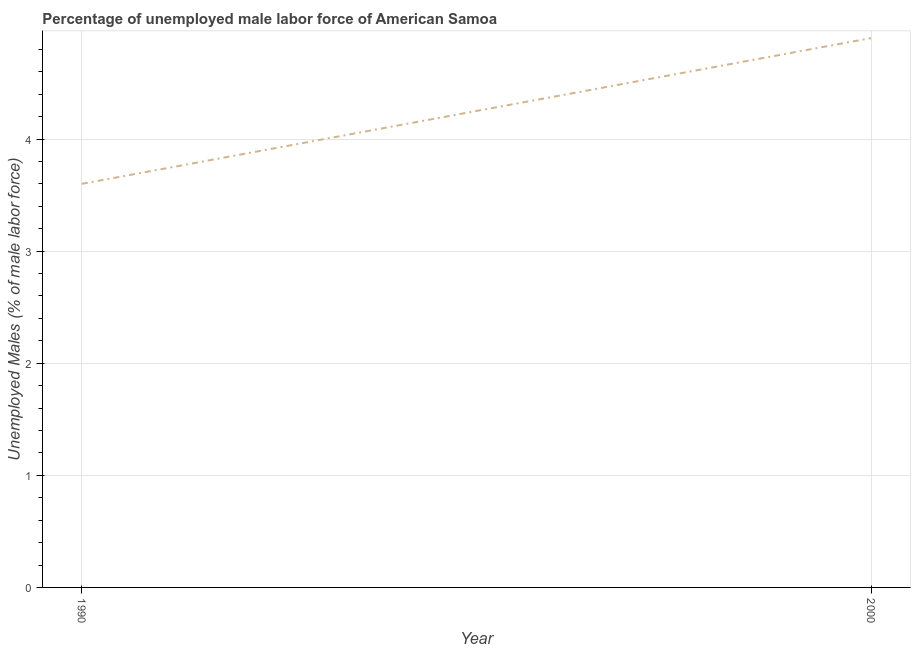What is the total unemployed male labour force in 1990?
Your answer should be very brief. 3.6. Across all years, what is the maximum total unemployed male labour force?
Your answer should be compact. 4.9. Across all years, what is the minimum total unemployed male labour force?
Make the answer very short. 3.6. What is the difference between the total unemployed male labour force in 1990 and 2000?
Your answer should be very brief. -1.3. What is the average total unemployed male labour force per year?
Keep it short and to the point. 4.25. What is the median total unemployed male labour force?
Offer a terse response. 4.25. In how many years, is the total unemployed male labour force greater than 0.6000000000000001 %?
Offer a very short reply. 2. Do a majority of the years between 1990 and 2000 (inclusive) have total unemployed male labour force greater than 4.6 %?
Provide a short and direct response. No. What is the ratio of the total unemployed male labour force in 1990 to that in 2000?
Keep it short and to the point. 0.73. Is the total unemployed male labour force in 1990 less than that in 2000?
Keep it short and to the point. Yes. In how many years, is the total unemployed male labour force greater than the average total unemployed male labour force taken over all years?
Offer a very short reply. 1. How many lines are there?
Keep it short and to the point. 1. What is the title of the graph?
Provide a short and direct response. Percentage of unemployed male labor force of American Samoa. What is the label or title of the X-axis?
Your answer should be compact. Year. What is the label or title of the Y-axis?
Make the answer very short. Unemployed Males (% of male labor force). What is the Unemployed Males (% of male labor force) in 1990?
Your answer should be very brief. 3.6. What is the Unemployed Males (% of male labor force) in 2000?
Keep it short and to the point. 4.9. What is the ratio of the Unemployed Males (% of male labor force) in 1990 to that in 2000?
Ensure brevity in your answer.  0.73. 